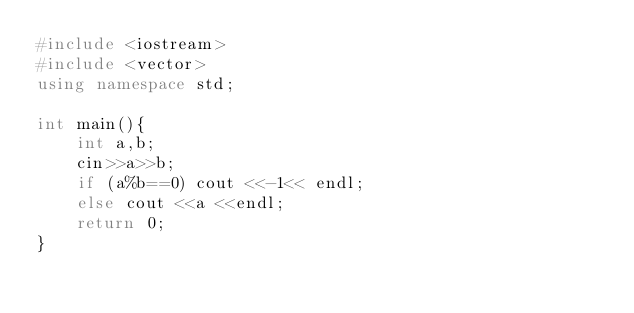Convert code to text. <code><loc_0><loc_0><loc_500><loc_500><_C++_>#include <iostream>
#include <vector>
using namespace std;

int main(){
    int a,b;
    cin>>a>>b;
    if (a%b==0) cout <<-1<< endl;
    else cout <<a <<endl;
    return 0;
}
</code> 